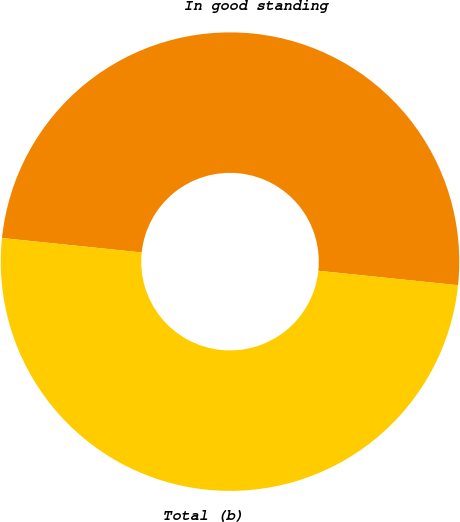Convert chart to OTSL. <chart><loc_0><loc_0><loc_500><loc_500><pie_chart><fcel>In good standing<fcel>Total (b)<nl><fcel>50.0%<fcel>50.0%<nl></chart> 